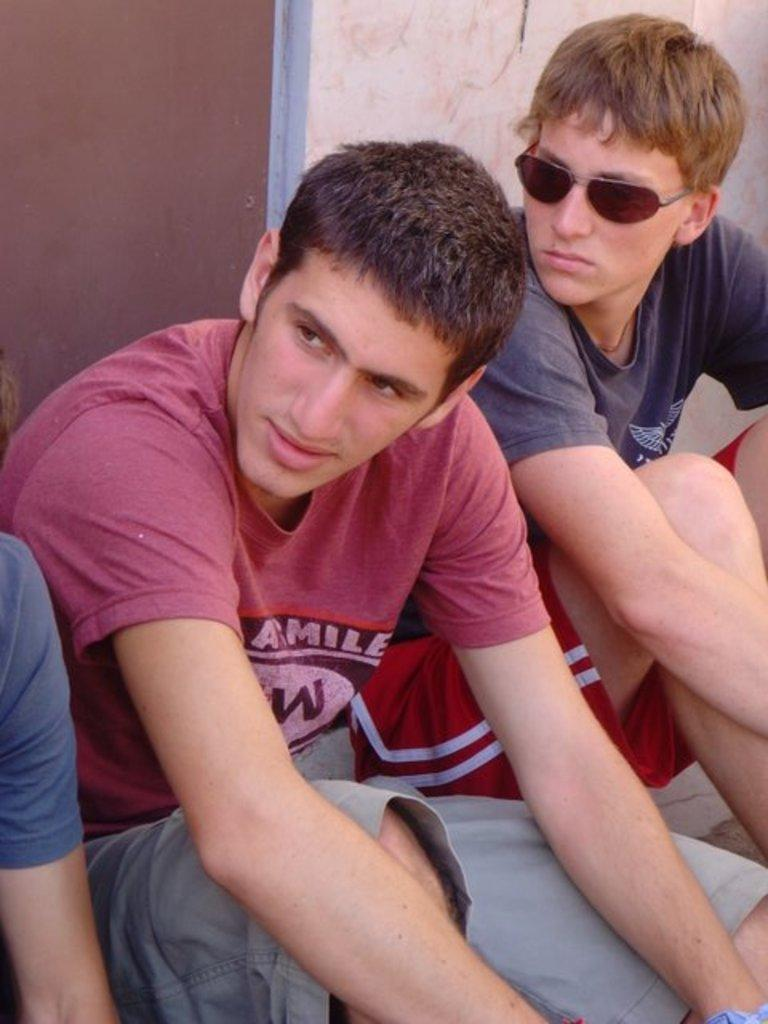How many people are in the image? There are three people in the image. What are the people doing in the image? The people are sitting on a staircase. What is behind the people in the image? There is a wall behind the people. What type of door can be seen in the image? There is a wooden door in the image. What type of tail can be seen on the people in the image? There are no tails visible on the people in the image. What team are the people in the image supporting? There is no indication of a team or any sports-related activity in the image. 